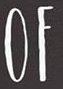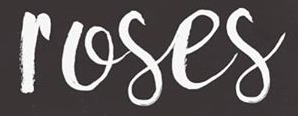What text is displayed in these images sequentially, separated by a semicolon? OF; roses 